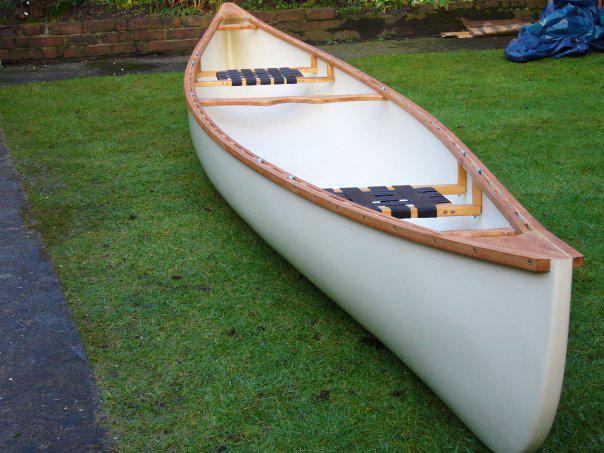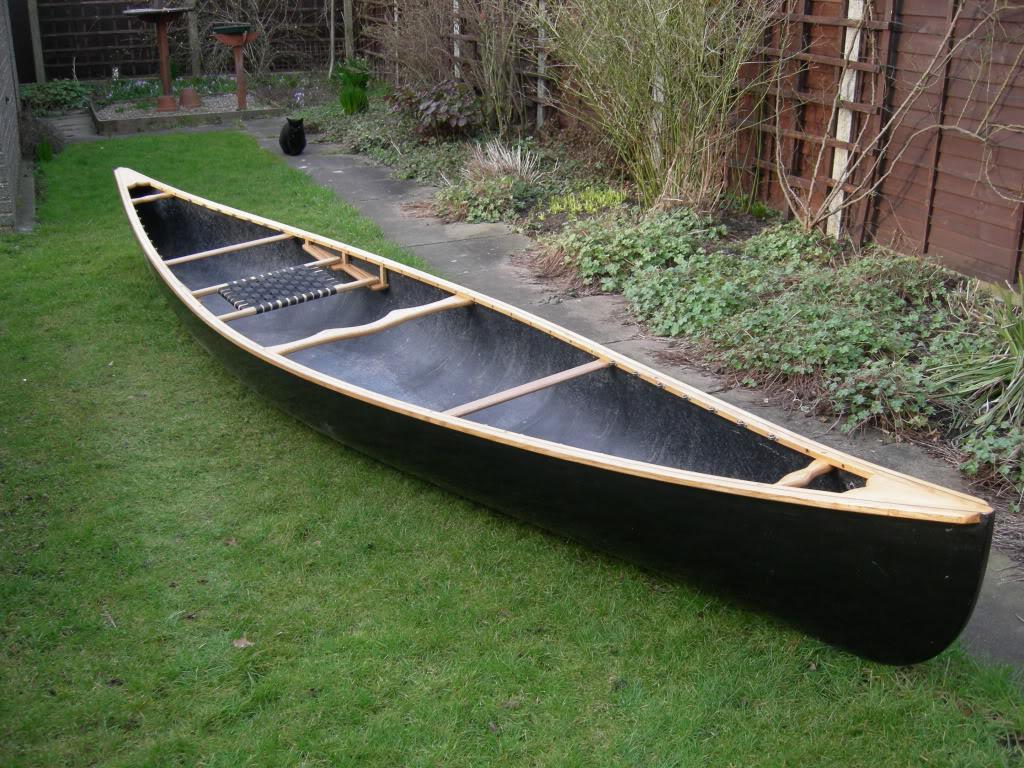The first image is the image on the left, the second image is the image on the right. Analyze the images presented: Is the assertion "Each image features an empty canoe sitting on green grass, and one image features a white canoe next to a strip of dark pavement, with a crumpled blue tarp behind it." valid? Answer yes or no. Yes. The first image is the image on the left, the second image is the image on the right. Given the left and right images, does the statement "Two canoes are sitting in the grass next to a building." hold true? Answer yes or no. Yes. 